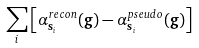<formula> <loc_0><loc_0><loc_500><loc_500>\sum _ { i } \left [ \alpha ^ { r e c o n } _ { { \mathbf s } _ { i } } ( { \mathbf g } ) - \alpha ^ { p s e u d o } _ { { \mathbf s } _ { i } } ( { \mathbf g } ) \right ]</formula> 